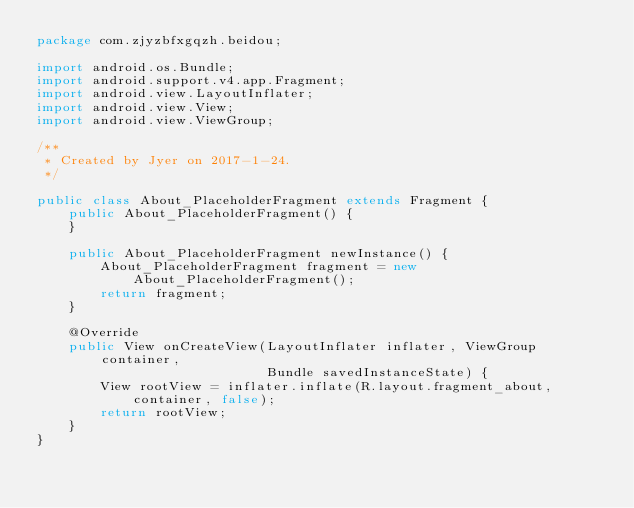<code> <loc_0><loc_0><loc_500><loc_500><_Java_>package com.zjyzbfxgqzh.beidou;

import android.os.Bundle;
import android.support.v4.app.Fragment;
import android.view.LayoutInflater;
import android.view.View;
import android.view.ViewGroup;

/**
 * Created by Jyer on 2017-1-24.
 */

public class About_PlaceholderFragment extends Fragment {
    public About_PlaceholderFragment() {
    }

    public About_PlaceholderFragment newInstance() {
        About_PlaceholderFragment fragment = new About_PlaceholderFragment();
        return fragment;
    }

    @Override
    public View onCreateView(LayoutInflater inflater, ViewGroup container,
                             Bundle savedInstanceState) {
        View rootView = inflater.inflate(R.layout.fragment_about, container, false);
        return rootView;
    }
}
</code> 